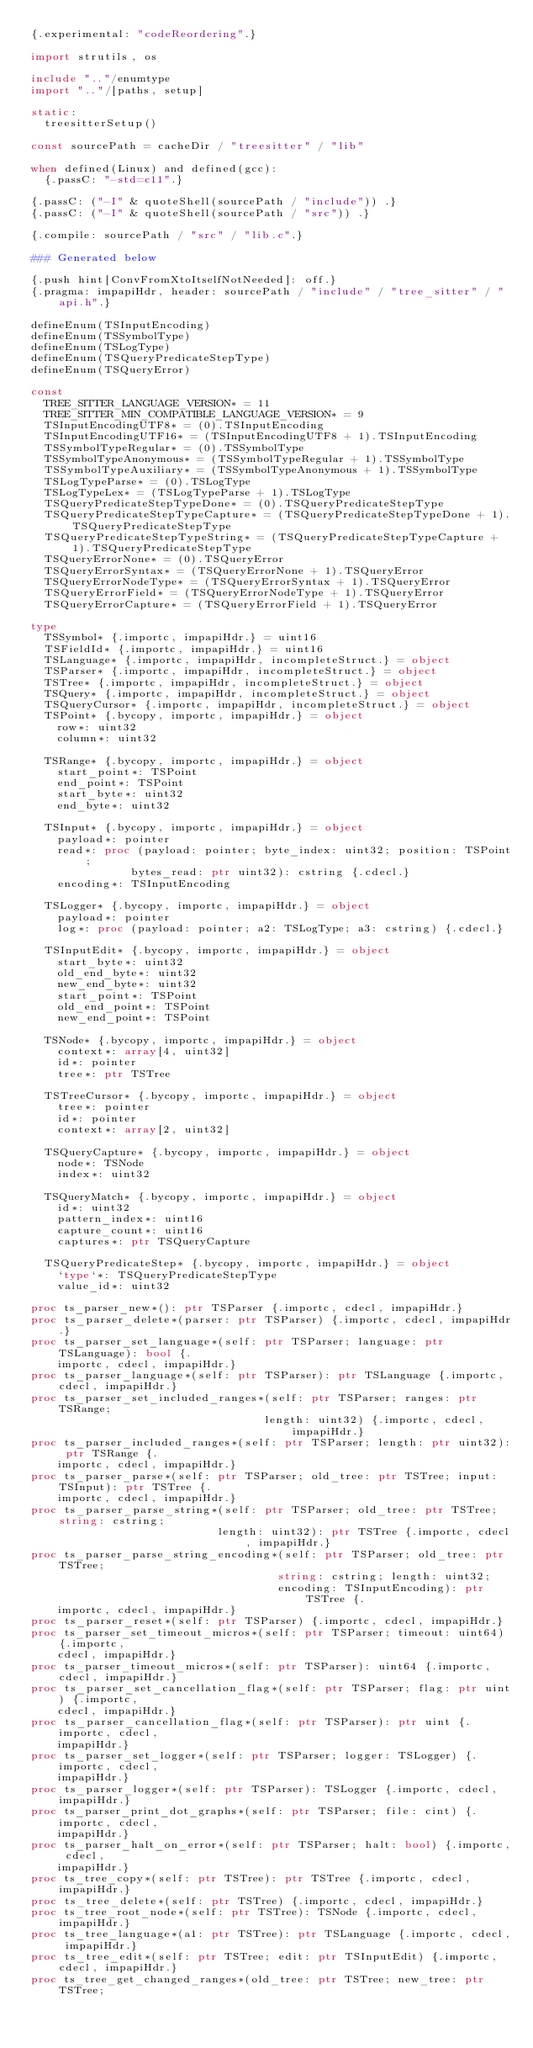<code> <loc_0><loc_0><loc_500><loc_500><_Nim_>{.experimental: "codeReordering".}

import strutils, os

include ".."/enumtype
import ".."/[paths, setup]

static:
  treesitterSetup()

const sourcePath = cacheDir / "treesitter" / "lib"

when defined(Linux) and defined(gcc):
  {.passC: "-std=c11".}

{.passC: ("-I" & quoteShell(sourcePath / "include")) .}
{.passC: ("-I" & quoteShell(sourcePath / "src")) .}

{.compile: sourcePath / "src" / "lib.c".}

### Generated below

{.push hint[ConvFromXtoItselfNotNeeded]: off.}
{.pragma: impapiHdr, header: sourcePath / "include" / "tree_sitter" / "api.h".}

defineEnum(TSInputEncoding)
defineEnum(TSSymbolType)
defineEnum(TSLogType)
defineEnum(TSQueryPredicateStepType)
defineEnum(TSQueryError)

const
  TREE_SITTER_LANGUAGE_VERSION* = 11
  TREE_SITTER_MIN_COMPATIBLE_LANGUAGE_VERSION* = 9
  TSInputEncodingUTF8* = (0).TSInputEncoding
  TSInputEncodingUTF16* = (TSInputEncodingUTF8 + 1).TSInputEncoding
  TSSymbolTypeRegular* = (0).TSSymbolType
  TSSymbolTypeAnonymous* = (TSSymbolTypeRegular + 1).TSSymbolType
  TSSymbolTypeAuxiliary* = (TSSymbolTypeAnonymous + 1).TSSymbolType
  TSLogTypeParse* = (0).TSLogType
  TSLogTypeLex* = (TSLogTypeParse + 1).TSLogType
  TSQueryPredicateStepTypeDone* = (0).TSQueryPredicateStepType
  TSQueryPredicateStepTypeCapture* = (TSQueryPredicateStepTypeDone + 1).TSQueryPredicateStepType
  TSQueryPredicateStepTypeString* = (TSQueryPredicateStepTypeCapture + 1).TSQueryPredicateStepType
  TSQueryErrorNone* = (0).TSQueryError
  TSQueryErrorSyntax* = (TSQueryErrorNone + 1).TSQueryError
  TSQueryErrorNodeType* = (TSQueryErrorSyntax + 1).TSQueryError
  TSQueryErrorField* = (TSQueryErrorNodeType + 1).TSQueryError
  TSQueryErrorCapture* = (TSQueryErrorField + 1).TSQueryError

type
  TSSymbol* {.importc, impapiHdr.} = uint16
  TSFieldId* {.importc, impapiHdr.} = uint16
  TSLanguage* {.importc, impapiHdr, incompleteStruct.} = object
  TSParser* {.importc, impapiHdr, incompleteStruct.} = object
  TSTree* {.importc, impapiHdr, incompleteStruct.} = object
  TSQuery* {.importc, impapiHdr, incompleteStruct.} = object
  TSQueryCursor* {.importc, impapiHdr, incompleteStruct.} = object
  TSPoint* {.bycopy, importc, impapiHdr.} = object
    row*: uint32
    column*: uint32

  TSRange* {.bycopy, importc, impapiHdr.} = object
    start_point*: TSPoint
    end_point*: TSPoint
    start_byte*: uint32
    end_byte*: uint32

  TSInput* {.bycopy, importc, impapiHdr.} = object
    payload*: pointer
    read*: proc (payload: pointer; byte_index: uint32; position: TSPoint;
               bytes_read: ptr uint32): cstring {.cdecl.}
    encoding*: TSInputEncoding

  TSLogger* {.bycopy, importc, impapiHdr.} = object
    payload*: pointer
    log*: proc (payload: pointer; a2: TSLogType; a3: cstring) {.cdecl.}

  TSInputEdit* {.bycopy, importc, impapiHdr.} = object
    start_byte*: uint32
    old_end_byte*: uint32
    new_end_byte*: uint32
    start_point*: TSPoint
    old_end_point*: TSPoint
    new_end_point*: TSPoint

  TSNode* {.bycopy, importc, impapiHdr.} = object
    context*: array[4, uint32]
    id*: pointer
    tree*: ptr TSTree

  TSTreeCursor* {.bycopy, importc, impapiHdr.} = object
    tree*: pointer
    id*: pointer
    context*: array[2, uint32]

  TSQueryCapture* {.bycopy, importc, impapiHdr.} = object
    node*: TSNode
    index*: uint32

  TSQueryMatch* {.bycopy, importc, impapiHdr.} = object
    id*: uint32
    pattern_index*: uint16
    capture_count*: uint16
    captures*: ptr TSQueryCapture

  TSQueryPredicateStep* {.bycopy, importc, impapiHdr.} = object
    `type`*: TSQueryPredicateStepType
    value_id*: uint32

proc ts_parser_new*(): ptr TSParser {.importc, cdecl, impapiHdr.}
proc ts_parser_delete*(parser: ptr TSParser) {.importc, cdecl, impapiHdr.}
proc ts_parser_set_language*(self: ptr TSParser; language: ptr TSLanguage): bool {.
    importc, cdecl, impapiHdr.}
proc ts_parser_language*(self: ptr TSParser): ptr TSLanguage {.importc, cdecl, impapiHdr.}
proc ts_parser_set_included_ranges*(self: ptr TSParser; ranges: ptr TSRange;
                                   length: uint32) {.importc, cdecl, impapiHdr.}
proc ts_parser_included_ranges*(self: ptr TSParser; length: ptr uint32): ptr TSRange {.
    importc, cdecl, impapiHdr.}
proc ts_parser_parse*(self: ptr TSParser; old_tree: ptr TSTree; input: TSInput): ptr TSTree {.
    importc, cdecl, impapiHdr.}
proc ts_parser_parse_string*(self: ptr TSParser; old_tree: ptr TSTree; string: cstring;
                            length: uint32): ptr TSTree {.importc, cdecl, impapiHdr.}
proc ts_parser_parse_string_encoding*(self: ptr TSParser; old_tree: ptr TSTree;
                                     string: cstring; length: uint32;
                                     encoding: TSInputEncoding): ptr TSTree {.
    importc, cdecl, impapiHdr.}
proc ts_parser_reset*(self: ptr TSParser) {.importc, cdecl, impapiHdr.}
proc ts_parser_set_timeout_micros*(self: ptr TSParser; timeout: uint64) {.importc,
    cdecl, impapiHdr.}
proc ts_parser_timeout_micros*(self: ptr TSParser): uint64 {.importc, cdecl, impapiHdr.}
proc ts_parser_set_cancellation_flag*(self: ptr TSParser; flag: ptr uint) {.importc,
    cdecl, impapiHdr.}
proc ts_parser_cancellation_flag*(self: ptr TSParser): ptr uint {.importc, cdecl,
    impapiHdr.}
proc ts_parser_set_logger*(self: ptr TSParser; logger: TSLogger) {.importc, cdecl,
    impapiHdr.}
proc ts_parser_logger*(self: ptr TSParser): TSLogger {.importc, cdecl, impapiHdr.}
proc ts_parser_print_dot_graphs*(self: ptr TSParser; file: cint) {.importc, cdecl,
    impapiHdr.}
proc ts_parser_halt_on_error*(self: ptr TSParser; halt: bool) {.importc, cdecl,
    impapiHdr.}
proc ts_tree_copy*(self: ptr TSTree): ptr TSTree {.importc, cdecl, impapiHdr.}
proc ts_tree_delete*(self: ptr TSTree) {.importc, cdecl, impapiHdr.}
proc ts_tree_root_node*(self: ptr TSTree): TSNode {.importc, cdecl, impapiHdr.}
proc ts_tree_language*(a1: ptr TSTree): ptr TSLanguage {.importc, cdecl, impapiHdr.}
proc ts_tree_edit*(self: ptr TSTree; edit: ptr TSInputEdit) {.importc, cdecl, impapiHdr.}
proc ts_tree_get_changed_ranges*(old_tree: ptr TSTree; new_tree: ptr TSTree;</code> 